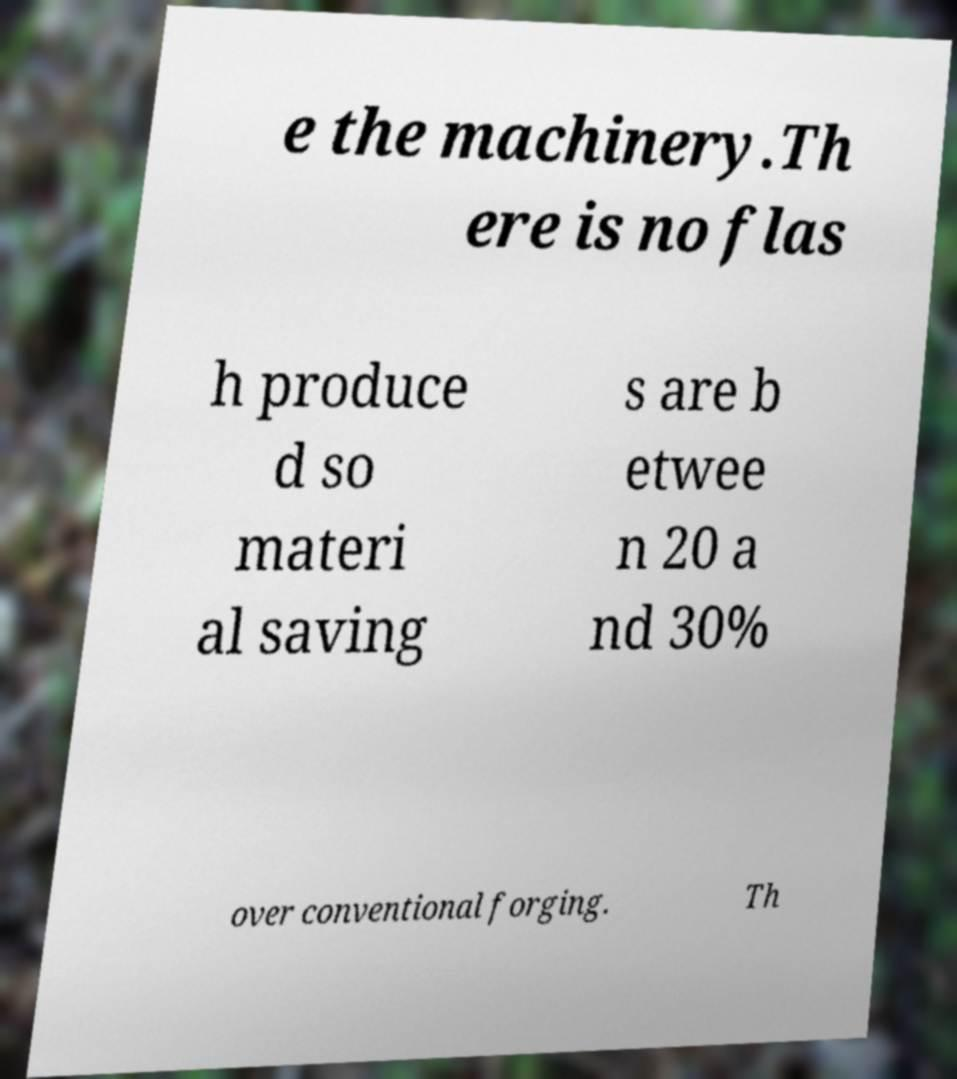Can you read and provide the text displayed in the image?This photo seems to have some interesting text. Can you extract and type it out for me? e the machinery.Th ere is no flas h produce d so materi al saving s are b etwee n 20 a nd 30% over conventional forging. Th 